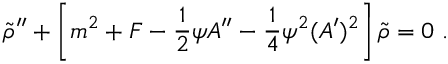Convert formula to latex. <formula><loc_0><loc_0><loc_500><loc_500>{ \widetilde { \rho } } ^ { \prime \prime } + \left [ m ^ { 2 } + F - { \frac { 1 } { 2 } } \psi A ^ { \prime \prime } - { \frac { 1 } { 4 } } \psi ^ { 2 } ( A ^ { \prime } ) ^ { 2 } \right ] { \widetilde { \rho } } = 0 .</formula> 